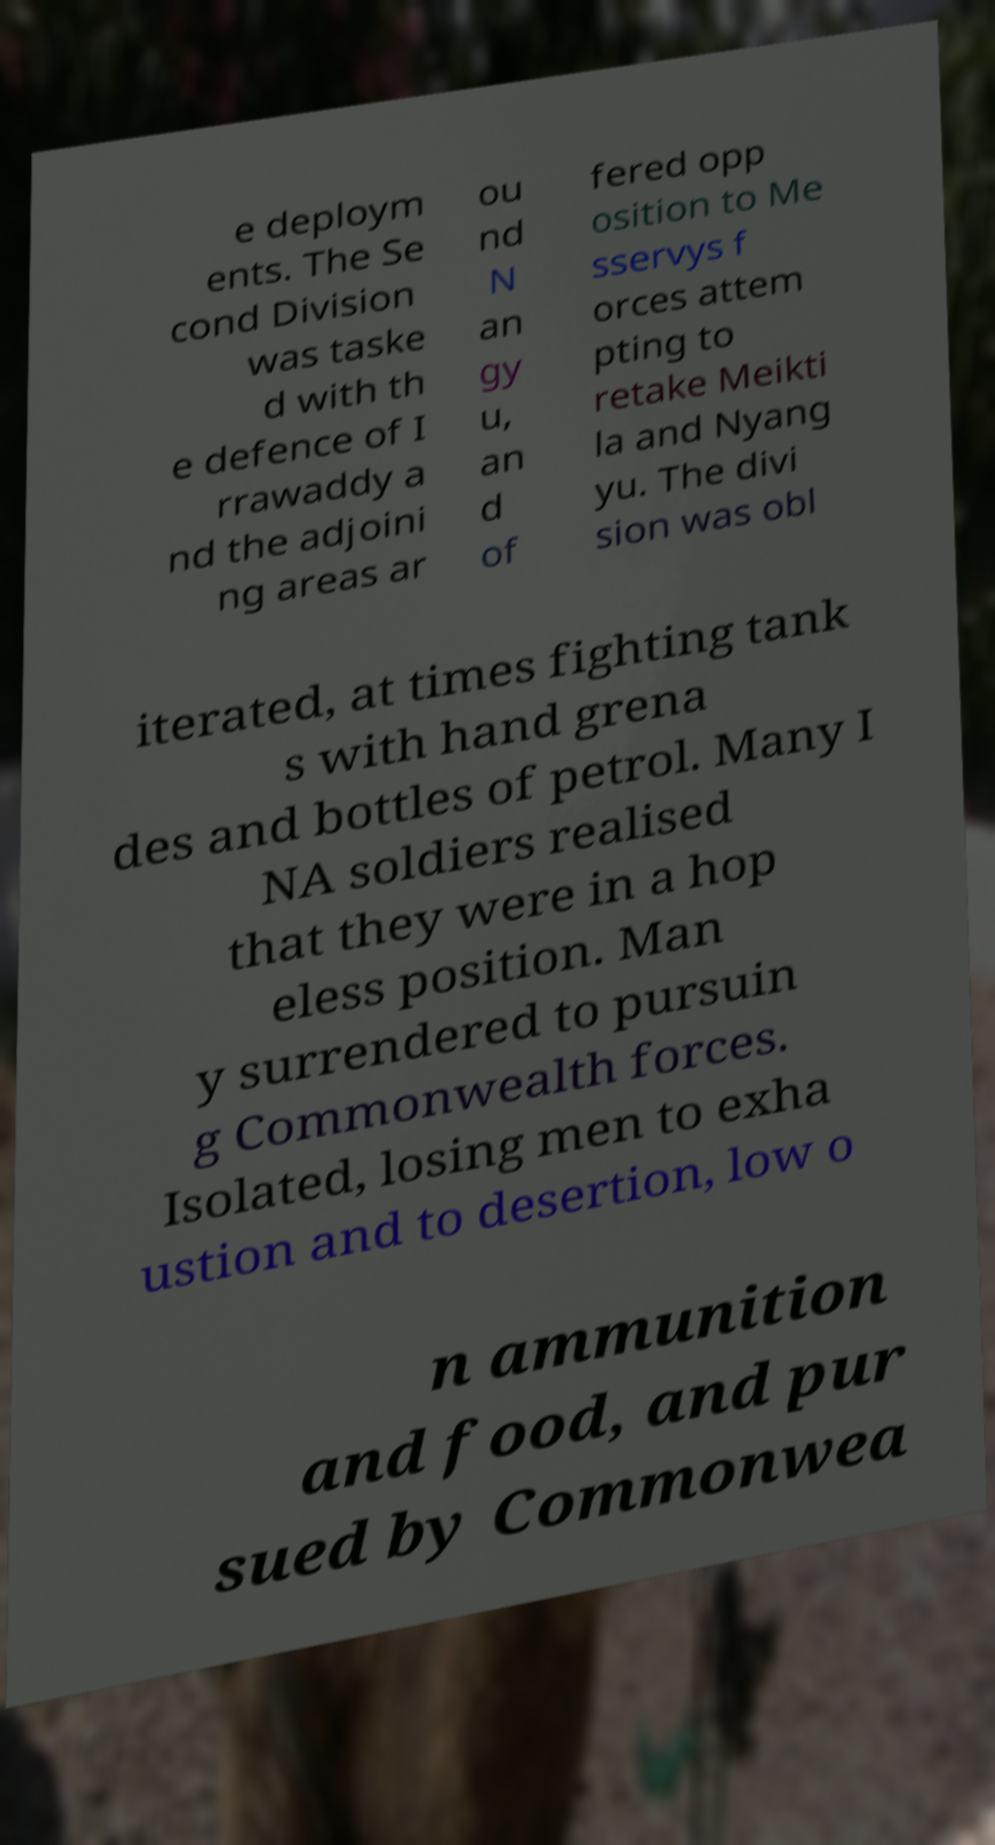Could you assist in decoding the text presented in this image and type it out clearly? e deploym ents. The Se cond Division was taske d with th e defence of I rrawaddy a nd the adjoini ng areas ar ou nd N an gy u, an d of fered opp osition to Me sservys f orces attem pting to retake Meikti la and Nyang yu. The divi sion was obl iterated, at times fighting tank s with hand grena des and bottles of petrol. Many I NA soldiers realised that they were in a hop eless position. Man y surrendered to pursuin g Commonwealth forces. Isolated, losing men to exha ustion and to desertion, low o n ammunition and food, and pur sued by Commonwea 